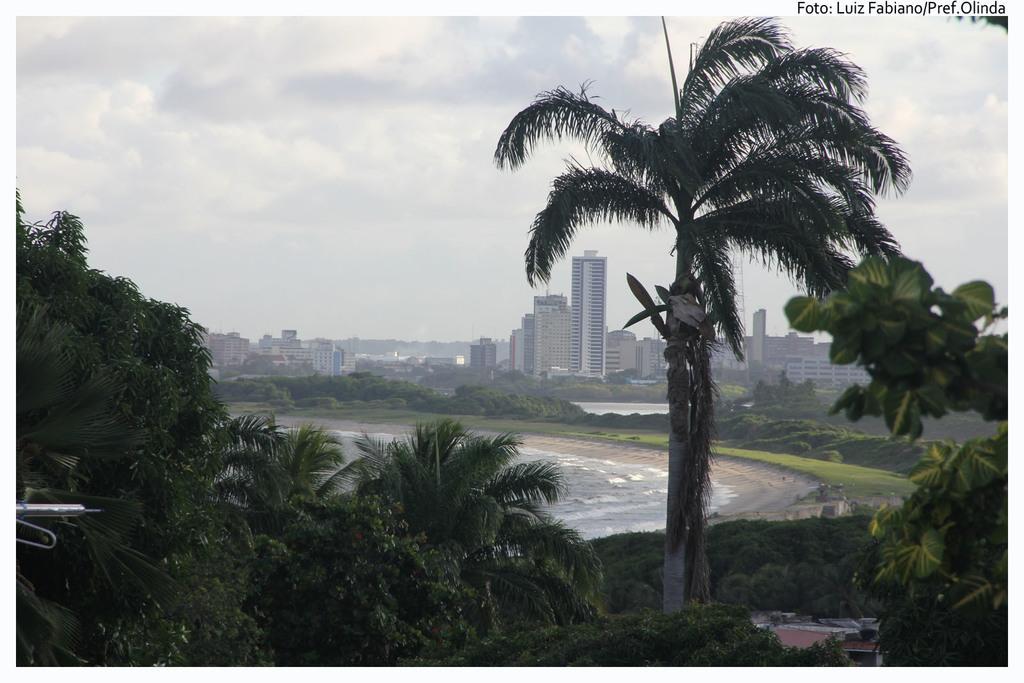Describe this image in one or two sentences. In the image there is a water surface and around that water surface there are many trees and plants and in the background there are many buildings. 